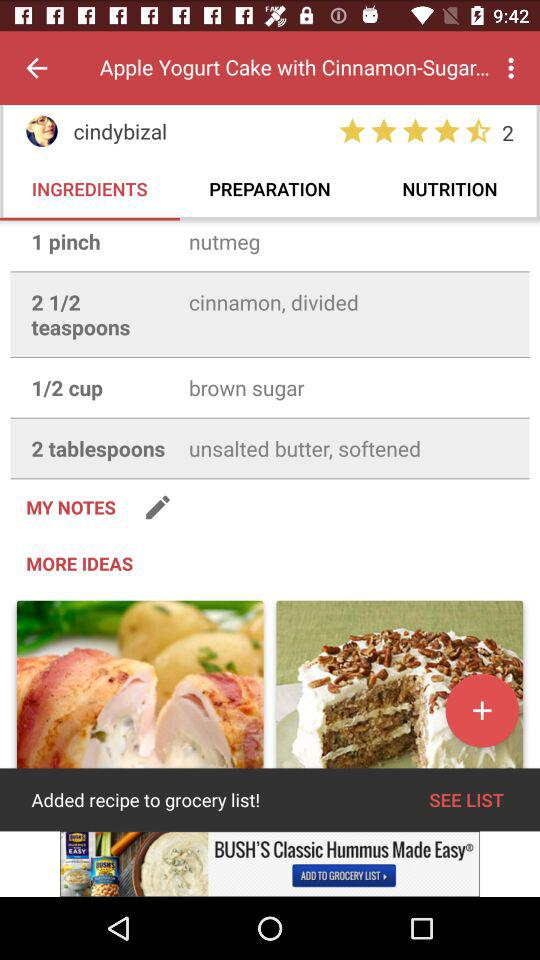What is the name of the dish? The name of the dish is "Apple Yogurt Cake with Cinnamon-Sugar...". 